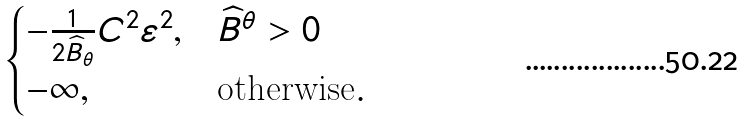<formula> <loc_0><loc_0><loc_500><loc_500>\begin{cases} - \frac { 1 } { 2 \widehat { B } _ { \theta } } C ^ { 2 } \varepsilon ^ { 2 } , & \widehat { B } ^ { \theta } > 0 \\ - \infty , & \text {otherwise} . \end{cases}</formula> 